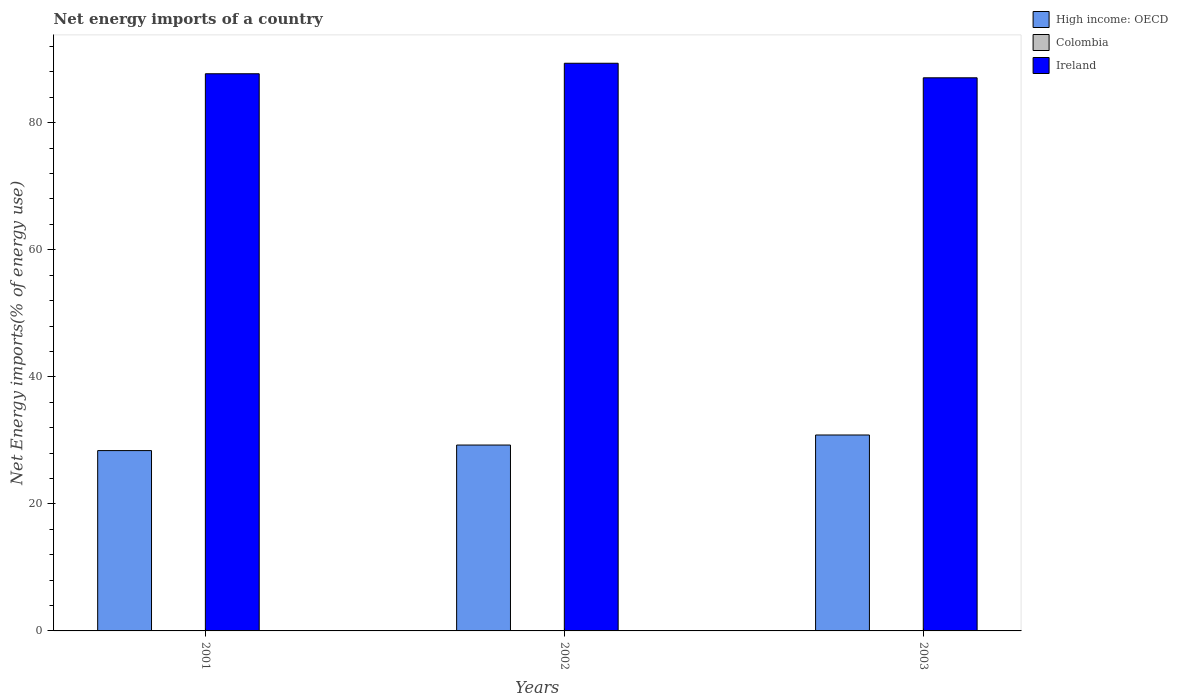Are the number of bars per tick equal to the number of legend labels?
Your response must be concise. No. Are the number of bars on each tick of the X-axis equal?
Your answer should be very brief. Yes. How many bars are there on the 1st tick from the left?
Your answer should be compact. 2. How many bars are there on the 2nd tick from the right?
Your response must be concise. 2. What is the label of the 1st group of bars from the left?
Offer a terse response. 2001. What is the net energy imports in High income: OECD in 2001?
Make the answer very short. 28.39. Across all years, what is the maximum net energy imports in Ireland?
Provide a short and direct response. 89.36. Across all years, what is the minimum net energy imports in High income: OECD?
Keep it short and to the point. 28.39. In which year was the net energy imports in Ireland maximum?
Ensure brevity in your answer.  2002. What is the difference between the net energy imports in High income: OECD in 2001 and that in 2003?
Your answer should be compact. -2.45. What is the difference between the net energy imports in High income: OECD in 2003 and the net energy imports in Ireland in 2002?
Keep it short and to the point. -58.52. What is the average net energy imports in High income: OECD per year?
Keep it short and to the point. 29.5. In the year 2002, what is the difference between the net energy imports in Ireland and net energy imports in High income: OECD?
Offer a terse response. 60.1. What is the ratio of the net energy imports in Ireland in 2001 to that in 2003?
Your answer should be compact. 1.01. What is the difference between the highest and the second highest net energy imports in Ireland?
Offer a terse response. 1.65. What is the difference between the highest and the lowest net energy imports in Ireland?
Make the answer very short. 2.29. In how many years, is the net energy imports in High income: OECD greater than the average net energy imports in High income: OECD taken over all years?
Give a very brief answer. 1. Is the sum of the net energy imports in Ireland in 2002 and 2003 greater than the maximum net energy imports in Colombia across all years?
Provide a succinct answer. Yes. How many bars are there?
Your answer should be compact. 6. Are the values on the major ticks of Y-axis written in scientific E-notation?
Provide a succinct answer. No. How are the legend labels stacked?
Your response must be concise. Vertical. What is the title of the graph?
Your answer should be compact. Net energy imports of a country. What is the label or title of the X-axis?
Your response must be concise. Years. What is the label or title of the Y-axis?
Your response must be concise. Net Energy imports(% of energy use). What is the Net Energy imports(% of energy use) in High income: OECD in 2001?
Your response must be concise. 28.39. What is the Net Energy imports(% of energy use) in Ireland in 2001?
Offer a very short reply. 87.71. What is the Net Energy imports(% of energy use) of High income: OECD in 2002?
Offer a very short reply. 29.26. What is the Net Energy imports(% of energy use) in Ireland in 2002?
Give a very brief answer. 89.36. What is the Net Energy imports(% of energy use) of High income: OECD in 2003?
Provide a succinct answer. 30.84. What is the Net Energy imports(% of energy use) of Colombia in 2003?
Make the answer very short. 0. What is the Net Energy imports(% of energy use) in Ireland in 2003?
Offer a very short reply. 87.07. Across all years, what is the maximum Net Energy imports(% of energy use) in High income: OECD?
Give a very brief answer. 30.84. Across all years, what is the maximum Net Energy imports(% of energy use) of Ireland?
Offer a very short reply. 89.36. Across all years, what is the minimum Net Energy imports(% of energy use) of High income: OECD?
Provide a short and direct response. 28.39. Across all years, what is the minimum Net Energy imports(% of energy use) of Ireland?
Your response must be concise. 87.07. What is the total Net Energy imports(% of energy use) of High income: OECD in the graph?
Your answer should be compact. 88.5. What is the total Net Energy imports(% of energy use) of Ireland in the graph?
Keep it short and to the point. 264.14. What is the difference between the Net Energy imports(% of energy use) in High income: OECD in 2001 and that in 2002?
Offer a terse response. -0.87. What is the difference between the Net Energy imports(% of energy use) in Ireland in 2001 and that in 2002?
Ensure brevity in your answer.  -1.65. What is the difference between the Net Energy imports(% of energy use) of High income: OECD in 2001 and that in 2003?
Make the answer very short. -2.45. What is the difference between the Net Energy imports(% of energy use) in Ireland in 2001 and that in 2003?
Provide a short and direct response. 0.64. What is the difference between the Net Energy imports(% of energy use) of High income: OECD in 2002 and that in 2003?
Keep it short and to the point. -1.58. What is the difference between the Net Energy imports(% of energy use) of Ireland in 2002 and that in 2003?
Your response must be concise. 2.29. What is the difference between the Net Energy imports(% of energy use) of High income: OECD in 2001 and the Net Energy imports(% of energy use) of Ireland in 2002?
Offer a terse response. -60.97. What is the difference between the Net Energy imports(% of energy use) in High income: OECD in 2001 and the Net Energy imports(% of energy use) in Ireland in 2003?
Your response must be concise. -58.68. What is the difference between the Net Energy imports(% of energy use) of High income: OECD in 2002 and the Net Energy imports(% of energy use) of Ireland in 2003?
Your answer should be compact. -57.81. What is the average Net Energy imports(% of energy use) of High income: OECD per year?
Make the answer very short. 29.5. What is the average Net Energy imports(% of energy use) in Colombia per year?
Your response must be concise. 0. What is the average Net Energy imports(% of energy use) of Ireland per year?
Your answer should be very brief. 88.05. In the year 2001, what is the difference between the Net Energy imports(% of energy use) of High income: OECD and Net Energy imports(% of energy use) of Ireland?
Give a very brief answer. -59.32. In the year 2002, what is the difference between the Net Energy imports(% of energy use) in High income: OECD and Net Energy imports(% of energy use) in Ireland?
Your response must be concise. -60.1. In the year 2003, what is the difference between the Net Energy imports(% of energy use) of High income: OECD and Net Energy imports(% of energy use) of Ireland?
Keep it short and to the point. -56.23. What is the ratio of the Net Energy imports(% of energy use) in High income: OECD in 2001 to that in 2002?
Keep it short and to the point. 0.97. What is the ratio of the Net Energy imports(% of energy use) of Ireland in 2001 to that in 2002?
Keep it short and to the point. 0.98. What is the ratio of the Net Energy imports(% of energy use) in High income: OECD in 2001 to that in 2003?
Provide a succinct answer. 0.92. What is the ratio of the Net Energy imports(% of energy use) of Ireland in 2001 to that in 2003?
Give a very brief answer. 1.01. What is the ratio of the Net Energy imports(% of energy use) of High income: OECD in 2002 to that in 2003?
Your answer should be very brief. 0.95. What is the ratio of the Net Energy imports(% of energy use) of Ireland in 2002 to that in 2003?
Provide a short and direct response. 1.03. What is the difference between the highest and the second highest Net Energy imports(% of energy use) of High income: OECD?
Offer a very short reply. 1.58. What is the difference between the highest and the second highest Net Energy imports(% of energy use) in Ireland?
Your answer should be very brief. 1.65. What is the difference between the highest and the lowest Net Energy imports(% of energy use) in High income: OECD?
Ensure brevity in your answer.  2.45. What is the difference between the highest and the lowest Net Energy imports(% of energy use) of Ireland?
Provide a succinct answer. 2.29. 